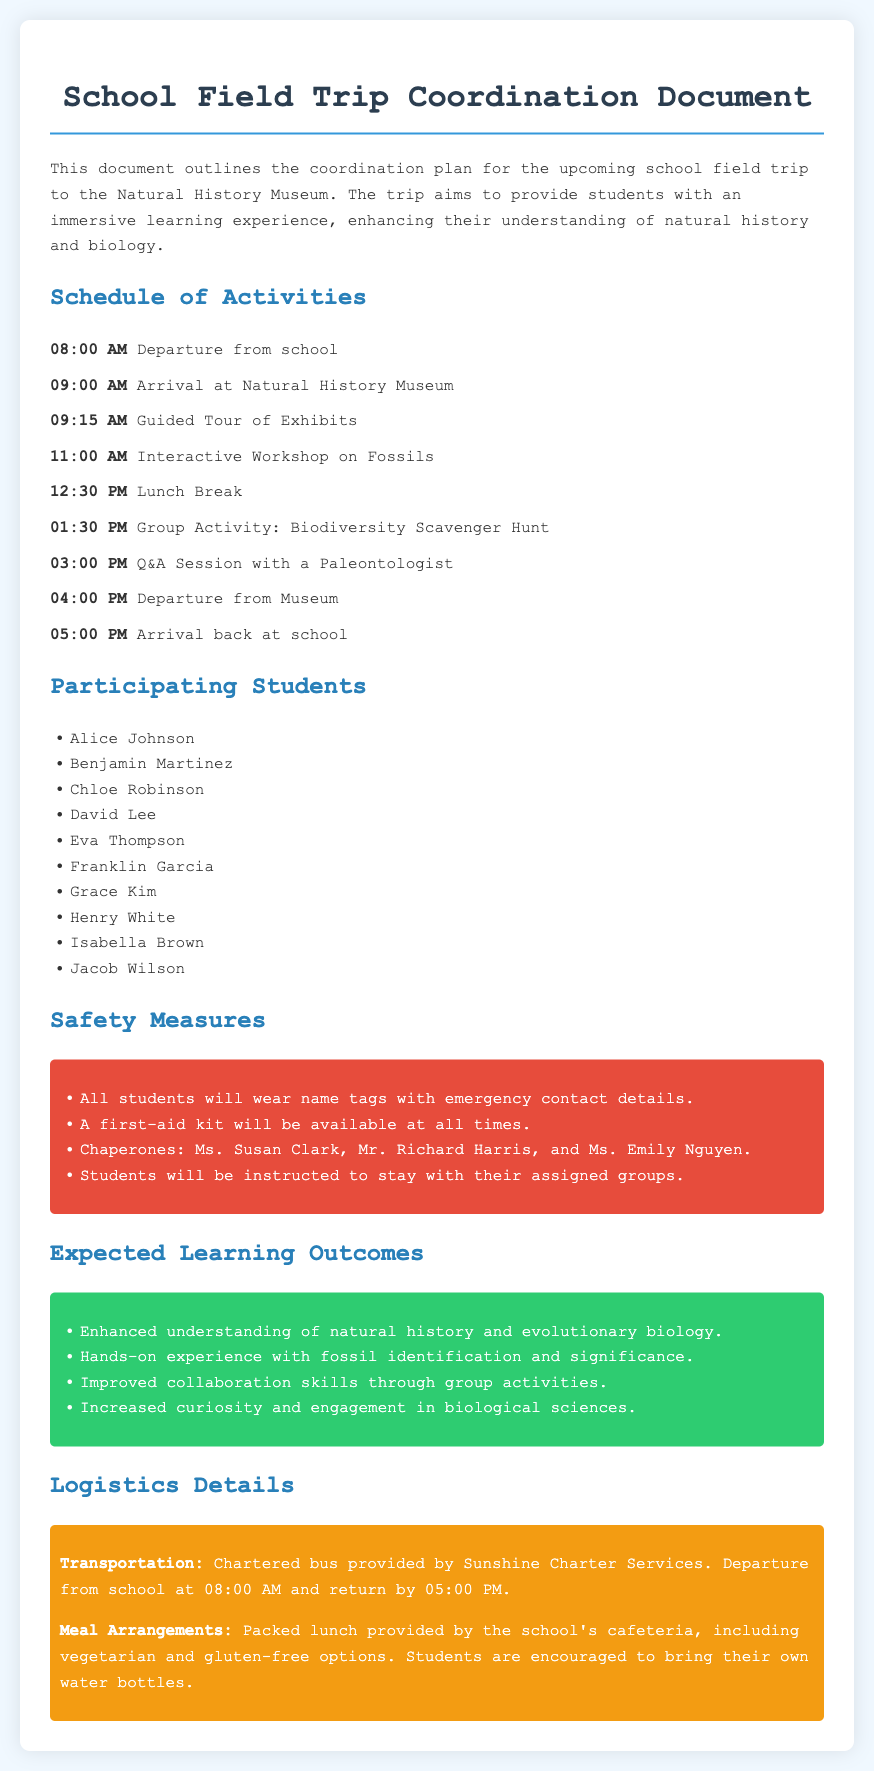What time does the trip depart from school? The scheduled departure time from school is mentioned in the document.
Answer: 08:00 AM Who provides the transportation for the trip? The document states the transportation provider for the trip.
Answer: Sunshine Charter Services How many students are participating in the trip? The list of participating students can be counted from the document.
Answer: 10 What is the first activity upon arrival at the museum? The document outlines the schedule of activities, with the first activity listed after arrival.
Answer: Guided Tour of Exhibits Name one safety measure highlighted in the document. The document includes several safety measures that are specified.
Answer: Name tags with emergency contact details What is one expected learning outcome of the trip? The document enumerates expected learning outcomes related to the field trip.
Answer: Enhanced understanding of natural history and evolutionary biology What type of meal is provided for the students? The meal arrangements section states what type of meal is offered.
Answer: Packed lunch What time does the group activity start? The schedule of activities provides the start time for the group activity.
Answer: 01:30 PM Who are the chaperones for the trip? The document lists the chaperones assigned for supervision during the trip.
Answer: Ms. Susan Clark, Mr. Richard Harris, and Ms. Emily Nguyen 